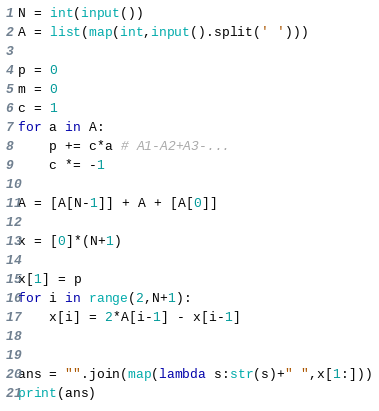<code> <loc_0><loc_0><loc_500><loc_500><_Python_>N = int(input())
A = list(map(int,input().split(' ')))

p = 0
m = 0
c = 1
for a in A:
	p += c*a # A1-A2+A3-...
	c *= -1

A = [A[N-1]] + A + [A[0]]

x = [0]*(N+1)

x[1] = p
for i in range(2,N+1):
	x[i] = 2*A[i-1] - x[i-1]


ans = "".join(map(lambda s:str(s)+" ",x[1:]))
print(ans)
</code> 